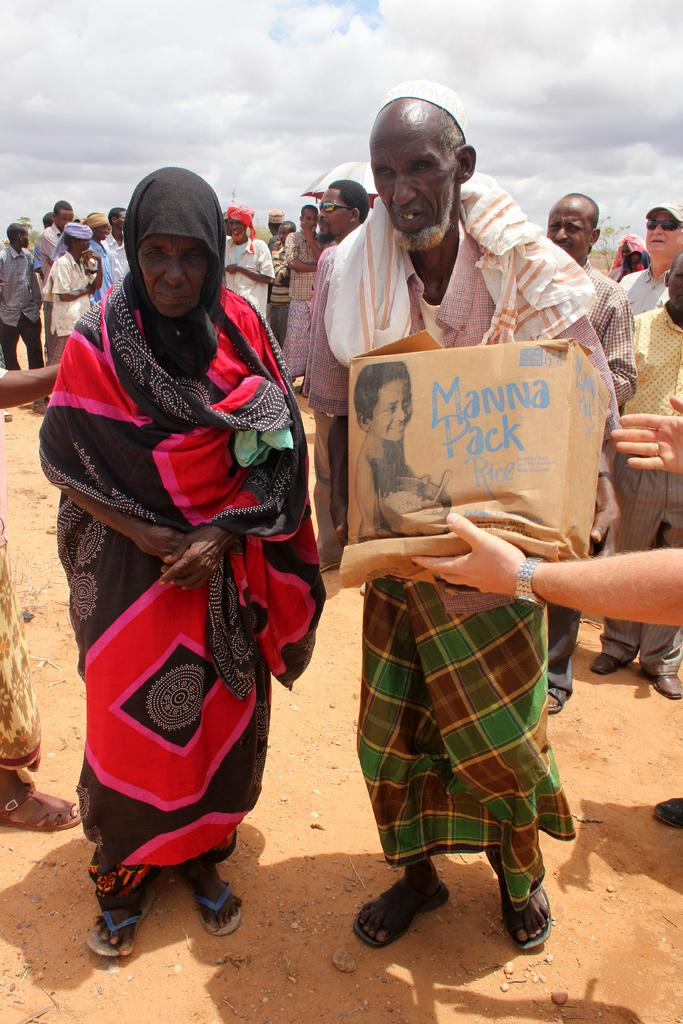What is happening in the image? There is a group of people standing in the image. Can you describe the object being held by one of the people? There is a person's hand holding a cardboard box on the right side of the image. What can be seen in the background of the image? The sky is visible in the background of the image. What type of sponge is being used by the dinosaurs in the image? There are no dinosaurs or sponges present in the image. What story is being told by the people in the image? The image does not depict a story being told; it simply shows a group of people standing. 